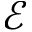Convert formula to latex. <formula><loc_0><loc_0><loc_500><loc_500>\mathcal { E }</formula> 